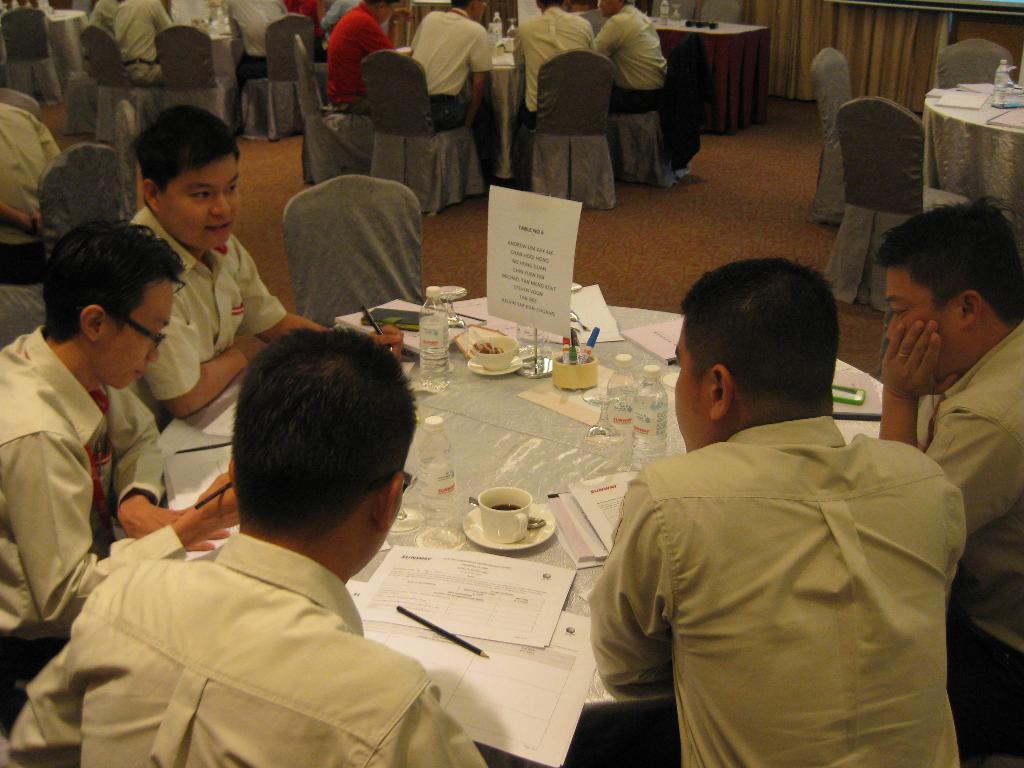How would you summarize this image in a sentence or two? In this image there are people sitting on the chairs. In front of them there are tables. On top of it there are water bottles, papers, cups and a few other objects. In the background of the image there is a curtain. 